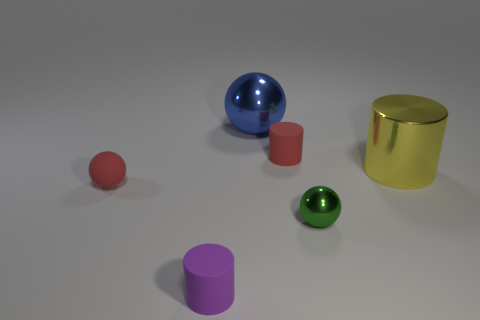There is a ball that is right of the blue metallic thing; what color is it?
Your answer should be compact. Green. What size is the sphere that is the same material as the purple thing?
Ensure brevity in your answer.  Small. There is a purple thing; does it have the same size as the red rubber object that is to the left of the purple matte object?
Your answer should be compact. Yes. What is the green thing left of the yellow object made of?
Your response must be concise. Metal. There is a small rubber cylinder in front of the small red sphere; how many big shiny cylinders are right of it?
Keep it short and to the point. 1. Are there any other metal things that have the same shape as the small purple thing?
Make the answer very short. Yes. There is a red matte thing that is behind the red rubber ball; is it the same size as the metallic sphere that is in front of the yellow cylinder?
Provide a succinct answer. Yes. What is the shape of the shiny object behind the small rubber cylinder behind the green thing?
Offer a terse response. Sphere. What number of metallic cylinders have the same size as the green sphere?
Offer a terse response. 0. Are there any small metal blocks?
Provide a succinct answer. No. 